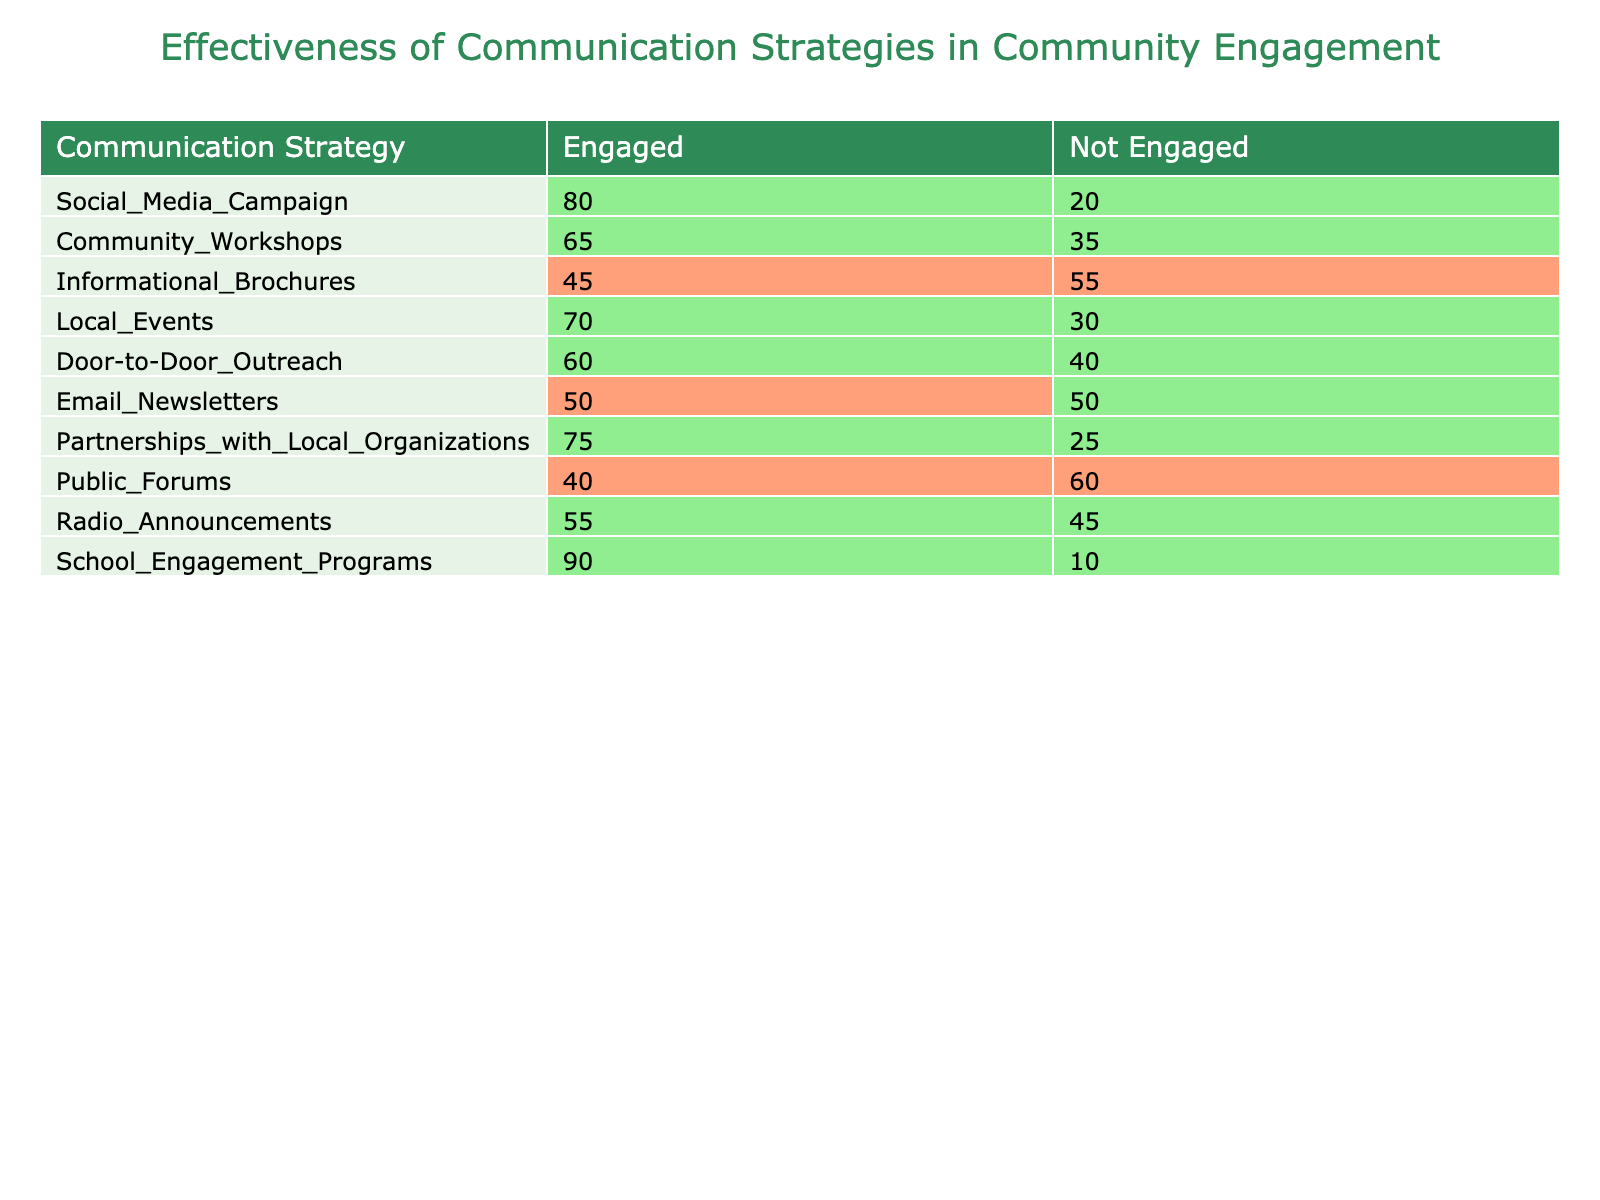What is the total number of people engaged by the School Engagement Programs? The table shows that 90 individuals were engaged through the School Engagement Programs. This is directly listed under the "Engaged" column for that strategy.
Answer: 90 Which communication strategy had the lowest engagement count? By examining the "Engaged" column, we see that the Informational Brochures had the lowest count of 45 individuals engaged.
Answer: Informational Brochures What is the difference in engagement between Community Workshops and Local Events? Community Workshops engaged 65 individuals, while Local Events engaged 70. The difference is 70 - 65 = 5.
Answer: 5 Did more people engage through Social Media Campaigns than through Email Newsletters? The table shows 80 individuals engaged through Social Media Campaigns and 50 engaged through Email Newsletters. Since 80 is greater than 50, more people engaged through Social Media Campaigns.
Answer: Yes What is the average number of engaged individuals across all communication strategies? To find the average, sum the engaged counts: 80 + 65 + 45 + 70 + 60 + 50 + 75 + 40 + 55 + 90 = 690. Then divide by the number of strategies, which is 10. The average is 690 / 10 = 69.
Answer: 69 Which strategy engaged the highest percentage of people (Engaged vs Not Engaged), and what is that percentage? To find the percentage engaged, calculate (Engaged / (Engaged + Not Engaged)) * 100 for each strategy. School Engagement Programs engaged 90 out of 100, which is 90%. Thus, it has the highest percentage of engagement.
Answer: School Engagement Programs, 90% If we combine the engagement from Partnerships with Local Organizations and Local Events, how many individuals were engaged in total? Partnerships with Local Organizations engaged 75 and Local Events engaged 70 individuals. The total engagement from both is 75 + 70 = 145.
Answer: 145 Is the number of people engaged through Community Workshops greater than those engaged through Radio Announcements? Community Workshops engaged 65 individuals, while Radio Announcements engaged 55. Since 65 is greater than 55, yes, Community Workshops had more engagement.
Answer: Yes 